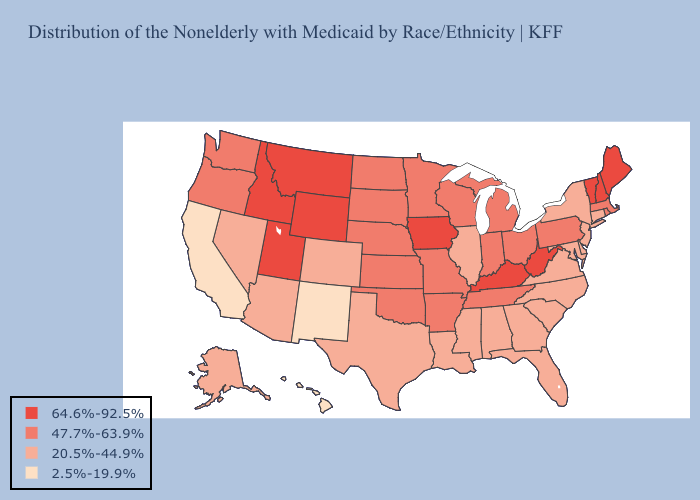What is the lowest value in states that border Washington?
Keep it brief. 47.7%-63.9%. Among the states that border California , does Arizona have the highest value?
Keep it brief. No. What is the lowest value in the West?
Quick response, please. 2.5%-19.9%. Does Maine have the highest value in the Northeast?
Be succinct. Yes. What is the value of New Jersey?
Concise answer only. 20.5%-44.9%. What is the value of Hawaii?
Write a very short answer. 2.5%-19.9%. Does the map have missing data?
Concise answer only. No. Which states have the highest value in the USA?
Write a very short answer. Idaho, Iowa, Kentucky, Maine, Montana, New Hampshire, Utah, Vermont, West Virginia, Wyoming. What is the value of Arizona?
Be succinct. 20.5%-44.9%. What is the value of Alabama?
Keep it brief. 20.5%-44.9%. Does Kentucky have the highest value in the USA?
Answer briefly. Yes. Does New Jersey have the highest value in the Northeast?
Write a very short answer. No. Does Nevada have a higher value than Washington?
Short answer required. No. Among the states that border Mississippi , does Alabama have the lowest value?
Quick response, please. Yes. What is the highest value in states that border New Mexico?
Be succinct. 64.6%-92.5%. 